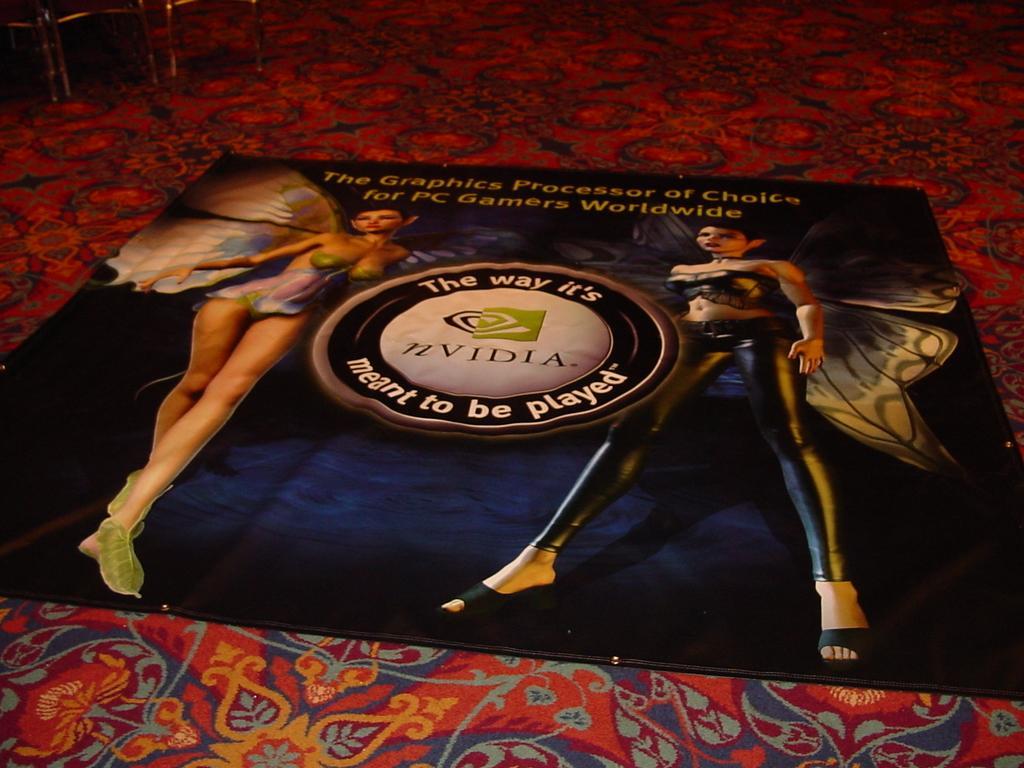Please provide a concise description of this image. In this image there is a cloth on the carpet , and in the background there are some objects. 